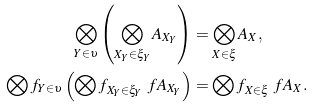<formula> <loc_0><loc_0><loc_500><loc_500>\bigotimes _ { Y \in \upsilon } \left ( \bigotimes _ { X _ { Y } \in \xi _ { Y } } A _ { X _ { Y } } \right ) & = \bigotimes _ { X \in \xi } A _ { X } , \\ \bigotimes f _ { Y \in \upsilon } \left ( \bigotimes f _ { X _ { Y } \in \xi _ { Y } } \ f { A } _ { X _ { Y } } \right ) & = \bigotimes f _ { X \in \xi } \ f { A } _ { X } .</formula> 